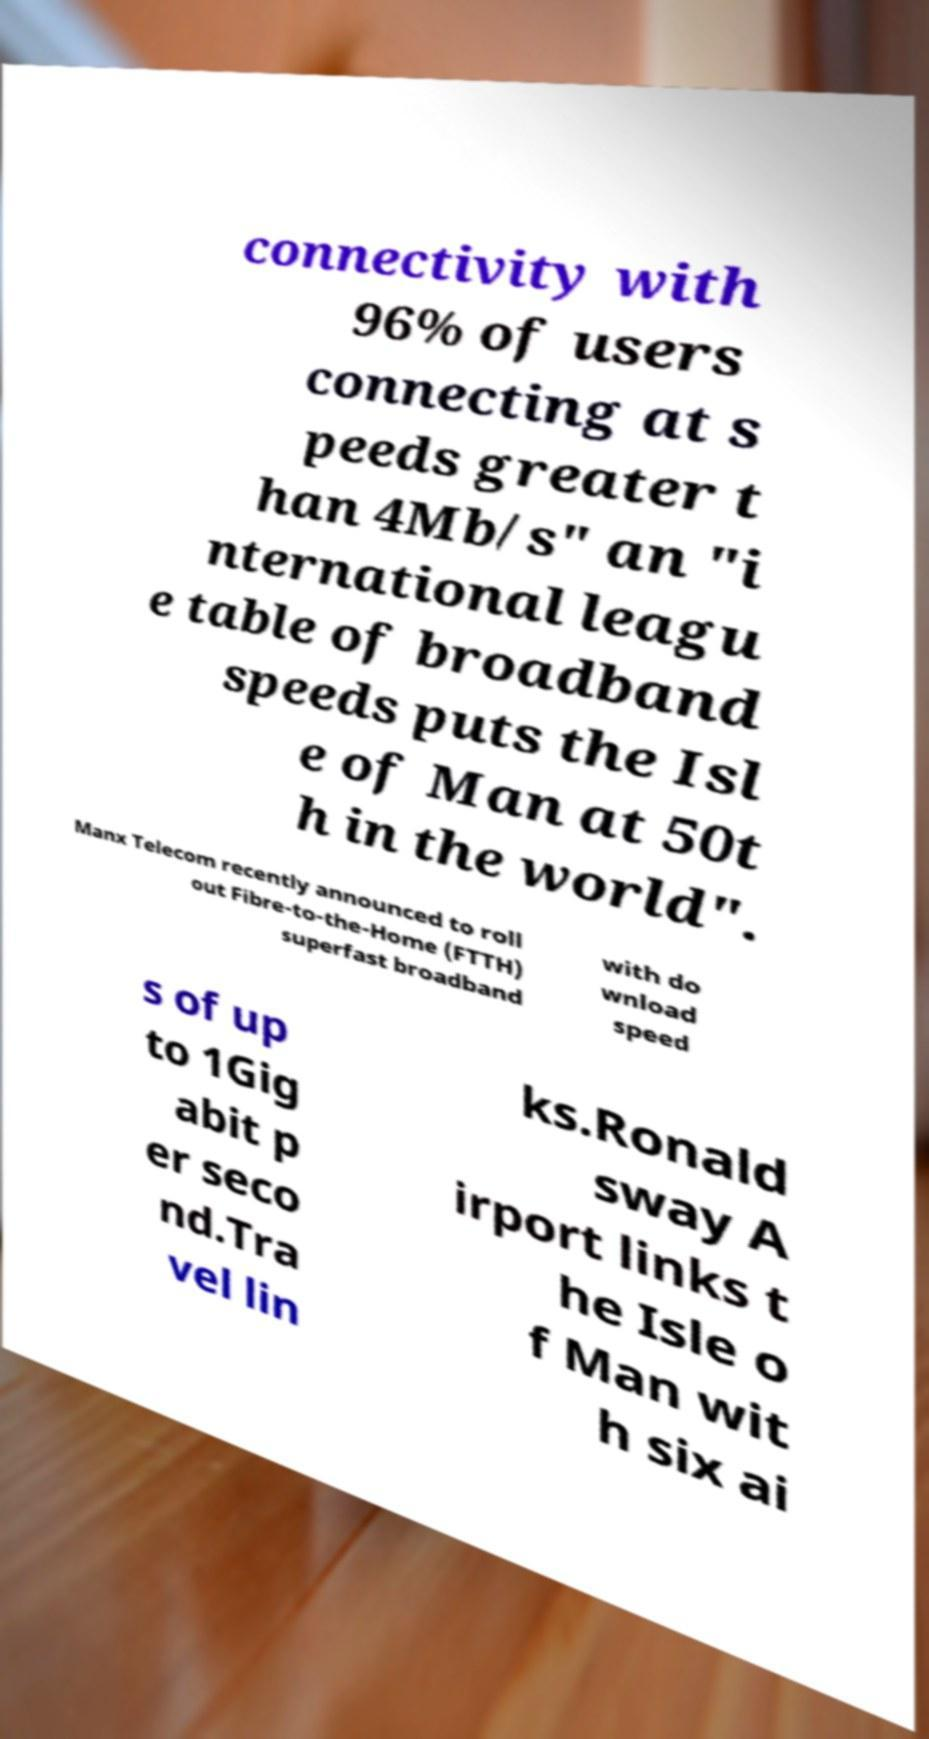There's text embedded in this image that I need extracted. Can you transcribe it verbatim? connectivity with 96% of users connecting at s peeds greater t han 4Mb/s" an "i nternational leagu e table of broadband speeds puts the Isl e of Man at 50t h in the world". Manx Telecom recently announced to roll out Fibre-to-the-Home (FTTH) superfast broadband with do wnload speed s of up to 1Gig abit p er seco nd.Tra vel lin ks.Ronald sway A irport links t he Isle o f Man wit h six ai 